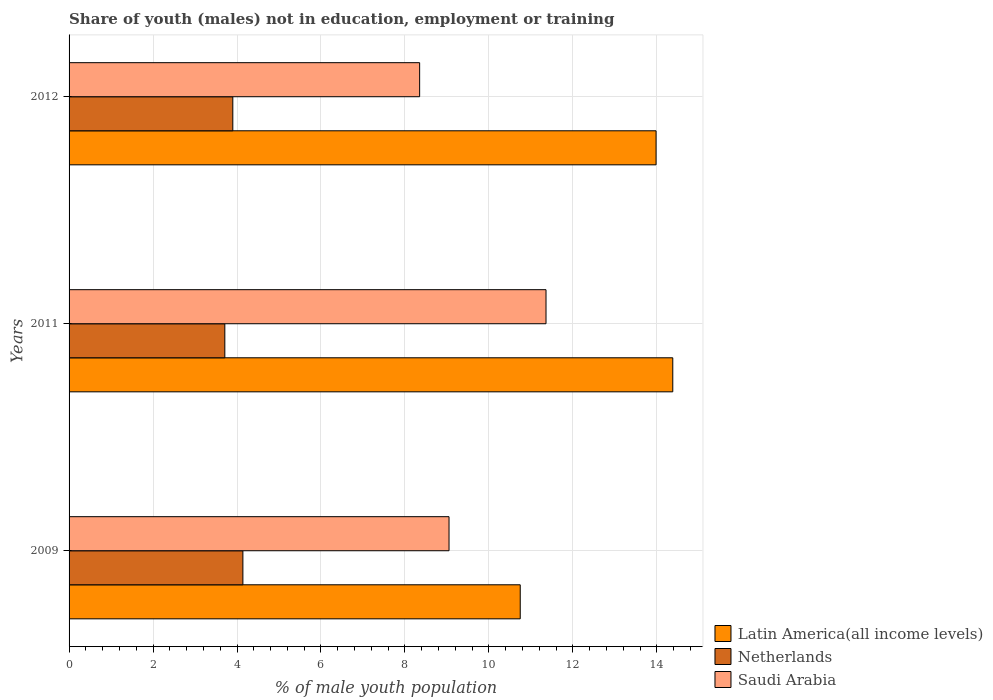Are the number of bars on each tick of the Y-axis equal?
Provide a succinct answer. Yes. In how many cases, is the number of bars for a given year not equal to the number of legend labels?
Keep it short and to the point. 0. What is the percentage of unemployed males population in in Netherlands in 2012?
Offer a very short reply. 3.9. Across all years, what is the maximum percentage of unemployed males population in in Netherlands?
Give a very brief answer. 4.14. Across all years, what is the minimum percentage of unemployed males population in in Saudi Arabia?
Your response must be concise. 8.35. In which year was the percentage of unemployed males population in in Netherlands maximum?
Ensure brevity in your answer.  2009. In which year was the percentage of unemployed males population in in Saudi Arabia minimum?
Provide a succinct answer. 2012. What is the total percentage of unemployed males population in in Netherlands in the graph?
Keep it short and to the point. 11.75. What is the difference between the percentage of unemployed males population in in Netherlands in 2011 and that in 2012?
Your answer should be very brief. -0.19. What is the difference between the percentage of unemployed males population in in Netherlands in 2009 and the percentage of unemployed males population in in Saudi Arabia in 2011?
Provide a short and direct response. -7.22. What is the average percentage of unemployed males population in in Netherlands per year?
Provide a succinct answer. 3.92. In the year 2012, what is the difference between the percentage of unemployed males population in in Netherlands and percentage of unemployed males population in in Saudi Arabia?
Your answer should be compact. -4.45. What is the ratio of the percentage of unemployed males population in in Netherlands in 2009 to that in 2011?
Provide a short and direct response. 1.12. Is the percentage of unemployed males population in in Saudi Arabia in 2009 less than that in 2011?
Your answer should be compact. Yes. Is the difference between the percentage of unemployed males population in in Netherlands in 2009 and 2011 greater than the difference between the percentage of unemployed males population in in Saudi Arabia in 2009 and 2011?
Offer a terse response. Yes. What is the difference between the highest and the second highest percentage of unemployed males population in in Netherlands?
Provide a short and direct response. 0.24. What is the difference between the highest and the lowest percentage of unemployed males population in in Saudi Arabia?
Offer a terse response. 3.01. In how many years, is the percentage of unemployed males population in in Latin America(all income levels) greater than the average percentage of unemployed males population in in Latin America(all income levels) taken over all years?
Provide a succinct answer. 2. Is the sum of the percentage of unemployed males population in in Saudi Arabia in 2009 and 2011 greater than the maximum percentage of unemployed males population in in Netherlands across all years?
Offer a terse response. Yes. What does the 3rd bar from the top in 2011 represents?
Your answer should be compact. Latin America(all income levels). Is it the case that in every year, the sum of the percentage of unemployed males population in in Netherlands and percentage of unemployed males population in in Saudi Arabia is greater than the percentage of unemployed males population in in Latin America(all income levels)?
Make the answer very short. No. How many bars are there?
Offer a terse response. 9. Are all the bars in the graph horizontal?
Ensure brevity in your answer.  Yes. How many years are there in the graph?
Provide a short and direct response. 3. What is the difference between two consecutive major ticks on the X-axis?
Your answer should be compact. 2. Are the values on the major ticks of X-axis written in scientific E-notation?
Provide a short and direct response. No. Does the graph contain grids?
Ensure brevity in your answer.  Yes. Where does the legend appear in the graph?
Keep it short and to the point. Bottom right. What is the title of the graph?
Your response must be concise. Share of youth (males) not in education, employment or training. What is the label or title of the X-axis?
Ensure brevity in your answer.  % of male youth population. What is the label or title of the Y-axis?
Provide a short and direct response. Years. What is the % of male youth population in Latin America(all income levels) in 2009?
Provide a short and direct response. 10.75. What is the % of male youth population of Netherlands in 2009?
Offer a terse response. 4.14. What is the % of male youth population in Saudi Arabia in 2009?
Give a very brief answer. 9.05. What is the % of male youth population of Latin America(all income levels) in 2011?
Provide a short and direct response. 14.38. What is the % of male youth population in Netherlands in 2011?
Your answer should be very brief. 3.71. What is the % of male youth population of Saudi Arabia in 2011?
Offer a terse response. 11.36. What is the % of male youth population of Latin America(all income levels) in 2012?
Your answer should be very brief. 13.98. What is the % of male youth population of Netherlands in 2012?
Your answer should be very brief. 3.9. What is the % of male youth population of Saudi Arabia in 2012?
Your answer should be compact. 8.35. Across all years, what is the maximum % of male youth population in Latin America(all income levels)?
Your response must be concise. 14.38. Across all years, what is the maximum % of male youth population of Netherlands?
Give a very brief answer. 4.14. Across all years, what is the maximum % of male youth population of Saudi Arabia?
Ensure brevity in your answer.  11.36. Across all years, what is the minimum % of male youth population of Latin America(all income levels)?
Provide a short and direct response. 10.75. Across all years, what is the minimum % of male youth population of Netherlands?
Provide a short and direct response. 3.71. Across all years, what is the minimum % of male youth population in Saudi Arabia?
Your answer should be compact. 8.35. What is the total % of male youth population of Latin America(all income levels) in the graph?
Offer a terse response. 39.11. What is the total % of male youth population in Netherlands in the graph?
Offer a terse response. 11.75. What is the total % of male youth population of Saudi Arabia in the graph?
Your answer should be compact. 28.76. What is the difference between the % of male youth population in Latin America(all income levels) in 2009 and that in 2011?
Keep it short and to the point. -3.63. What is the difference between the % of male youth population in Netherlands in 2009 and that in 2011?
Your response must be concise. 0.43. What is the difference between the % of male youth population in Saudi Arabia in 2009 and that in 2011?
Keep it short and to the point. -2.31. What is the difference between the % of male youth population of Latin America(all income levels) in 2009 and that in 2012?
Keep it short and to the point. -3.24. What is the difference between the % of male youth population of Netherlands in 2009 and that in 2012?
Keep it short and to the point. 0.24. What is the difference between the % of male youth population of Latin America(all income levels) in 2011 and that in 2012?
Provide a succinct answer. 0.4. What is the difference between the % of male youth population in Netherlands in 2011 and that in 2012?
Your answer should be compact. -0.19. What is the difference between the % of male youth population in Saudi Arabia in 2011 and that in 2012?
Give a very brief answer. 3.01. What is the difference between the % of male youth population in Latin America(all income levels) in 2009 and the % of male youth population in Netherlands in 2011?
Provide a succinct answer. 7.04. What is the difference between the % of male youth population in Latin America(all income levels) in 2009 and the % of male youth population in Saudi Arabia in 2011?
Make the answer very short. -0.61. What is the difference between the % of male youth population of Netherlands in 2009 and the % of male youth population of Saudi Arabia in 2011?
Give a very brief answer. -7.22. What is the difference between the % of male youth population in Latin America(all income levels) in 2009 and the % of male youth population in Netherlands in 2012?
Offer a terse response. 6.85. What is the difference between the % of male youth population of Latin America(all income levels) in 2009 and the % of male youth population of Saudi Arabia in 2012?
Your response must be concise. 2.4. What is the difference between the % of male youth population in Netherlands in 2009 and the % of male youth population in Saudi Arabia in 2012?
Your response must be concise. -4.21. What is the difference between the % of male youth population of Latin America(all income levels) in 2011 and the % of male youth population of Netherlands in 2012?
Your response must be concise. 10.48. What is the difference between the % of male youth population of Latin America(all income levels) in 2011 and the % of male youth population of Saudi Arabia in 2012?
Your answer should be very brief. 6.03. What is the difference between the % of male youth population of Netherlands in 2011 and the % of male youth population of Saudi Arabia in 2012?
Offer a terse response. -4.64. What is the average % of male youth population in Latin America(all income levels) per year?
Make the answer very short. 13.04. What is the average % of male youth population of Netherlands per year?
Offer a terse response. 3.92. What is the average % of male youth population of Saudi Arabia per year?
Offer a terse response. 9.59. In the year 2009, what is the difference between the % of male youth population in Latin America(all income levels) and % of male youth population in Netherlands?
Your answer should be compact. 6.61. In the year 2009, what is the difference between the % of male youth population in Latin America(all income levels) and % of male youth population in Saudi Arabia?
Your response must be concise. 1.7. In the year 2009, what is the difference between the % of male youth population in Netherlands and % of male youth population in Saudi Arabia?
Make the answer very short. -4.91. In the year 2011, what is the difference between the % of male youth population of Latin America(all income levels) and % of male youth population of Netherlands?
Your response must be concise. 10.67. In the year 2011, what is the difference between the % of male youth population in Latin America(all income levels) and % of male youth population in Saudi Arabia?
Ensure brevity in your answer.  3.02. In the year 2011, what is the difference between the % of male youth population of Netherlands and % of male youth population of Saudi Arabia?
Make the answer very short. -7.65. In the year 2012, what is the difference between the % of male youth population of Latin America(all income levels) and % of male youth population of Netherlands?
Keep it short and to the point. 10.08. In the year 2012, what is the difference between the % of male youth population of Latin America(all income levels) and % of male youth population of Saudi Arabia?
Your answer should be very brief. 5.63. In the year 2012, what is the difference between the % of male youth population in Netherlands and % of male youth population in Saudi Arabia?
Offer a very short reply. -4.45. What is the ratio of the % of male youth population in Latin America(all income levels) in 2009 to that in 2011?
Offer a very short reply. 0.75. What is the ratio of the % of male youth population in Netherlands in 2009 to that in 2011?
Provide a short and direct response. 1.12. What is the ratio of the % of male youth population in Saudi Arabia in 2009 to that in 2011?
Your answer should be very brief. 0.8. What is the ratio of the % of male youth population of Latin America(all income levels) in 2009 to that in 2012?
Your response must be concise. 0.77. What is the ratio of the % of male youth population of Netherlands in 2009 to that in 2012?
Offer a terse response. 1.06. What is the ratio of the % of male youth population in Saudi Arabia in 2009 to that in 2012?
Give a very brief answer. 1.08. What is the ratio of the % of male youth population of Latin America(all income levels) in 2011 to that in 2012?
Give a very brief answer. 1.03. What is the ratio of the % of male youth population in Netherlands in 2011 to that in 2012?
Provide a short and direct response. 0.95. What is the ratio of the % of male youth population in Saudi Arabia in 2011 to that in 2012?
Your response must be concise. 1.36. What is the difference between the highest and the second highest % of male youth population of Latin America(all income levels)?
Keep it short and to the point. 0.4. What is the difference between the highest and the second highest % of male youth population of Netherlands?
Your response must be concise. 0.24. What is the difference between the highest and the second highest % of male youth population in Saudi Arabia?
Your answer should be very brief. 2.31. What is the difference between the highest and the lowest % of male youth population in Latin America(all income levels)?
Provide a succinct answer. 3.63. What is the difference between the highest and the lowest % of male youth population of Netherlands?
Your answer should be very brief. 0.43. What is the difference between the highest and the lowest % of male youth population of Saudi Arabia?
Your answer should be compact. 3.01. 